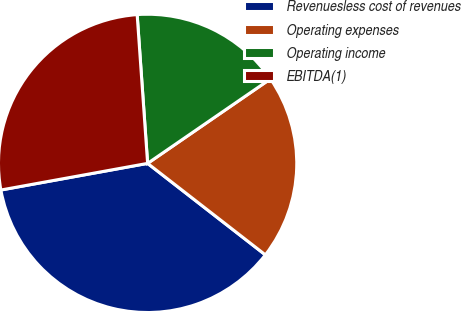<chart> <loc_0><loc_0><loc_500><loc_500><pie_chart><fcel>Revenuesless cost of revenues<fcel>Operating expenses<fcel>Operating income<fcel>EBITDA(1)<nl><fcel>36.63%<fcel>20.1%<fcel>16.53%<fcel>26.74%<nl></chart> 